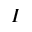<formula> <loc_0><loc_0><loc_500><loc_500>I</formula> 